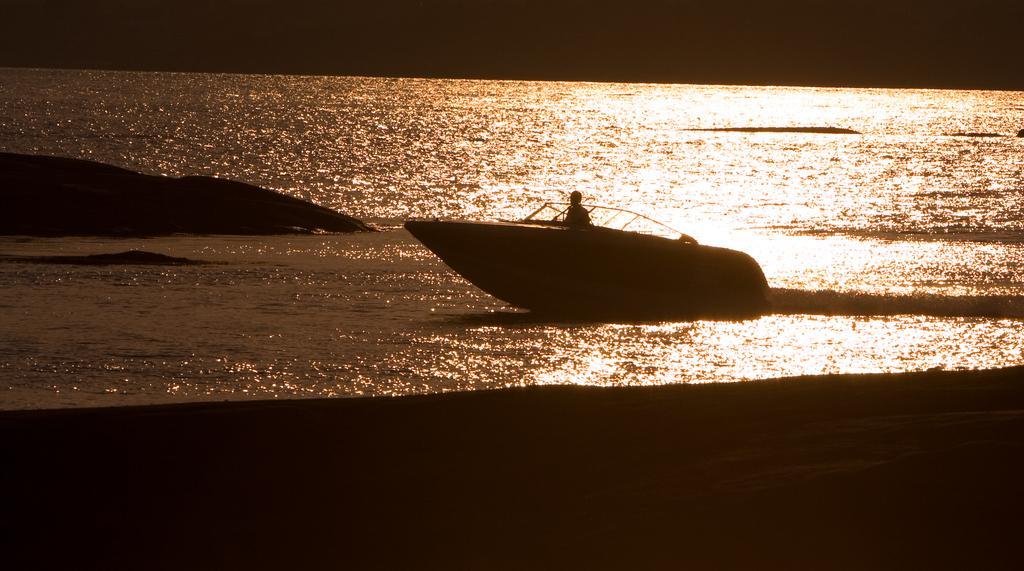Describe this image in one or two sentences. In this image, in the middle, we can see a boat which is drowning in the water. In the boat, we can see a person. On the left side, we can see some rocks. In the background, we can see water. In the middle of the image, we can see water in a lake, at the bottom, we can see black color. 